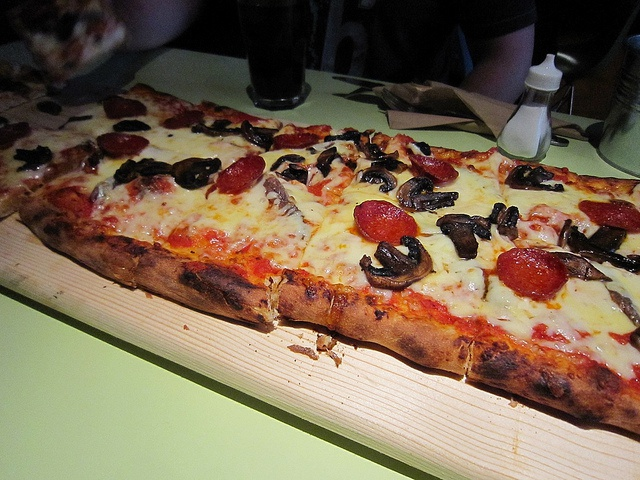Describe the objects in this image and their specific colors. I can see pizza in black, maroon, brown, and tan tones, dining table in black, khaki, beige, lightgreen, and tan tones, people in black and purple tones, cup in black and gray tones, and bottle in black and gray tones in this image. 